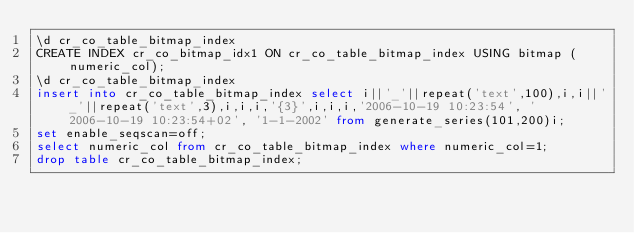Convert code to text. <code><loc_0><loc_0><loc_500><loc_500><_SQL_>\d cr_co_table_bitmap_index
CREATE INDEX cr_co_bitmap_idx1 ON cr_co_table_bitmap_index USING bitmap (numeric_col);
\d cr_co_table_bitmap_index
insert into cr_co_table_bitmap_index select i||'_'||repeat('text',100),i,i||'_'||repeat('text',3),i,i,i,'{3}',i,i,i,'2006-10-19 10:23:54', '2006-10-19 10:23:54+02', '1-1-2002' from generate_series(101,200)i;
set enable_seqscan=off;
select numeric_col from cr_co_table_bitmap_index where numeric_col=1;
drop table cr_co_table_bitmap_index;
</code> 